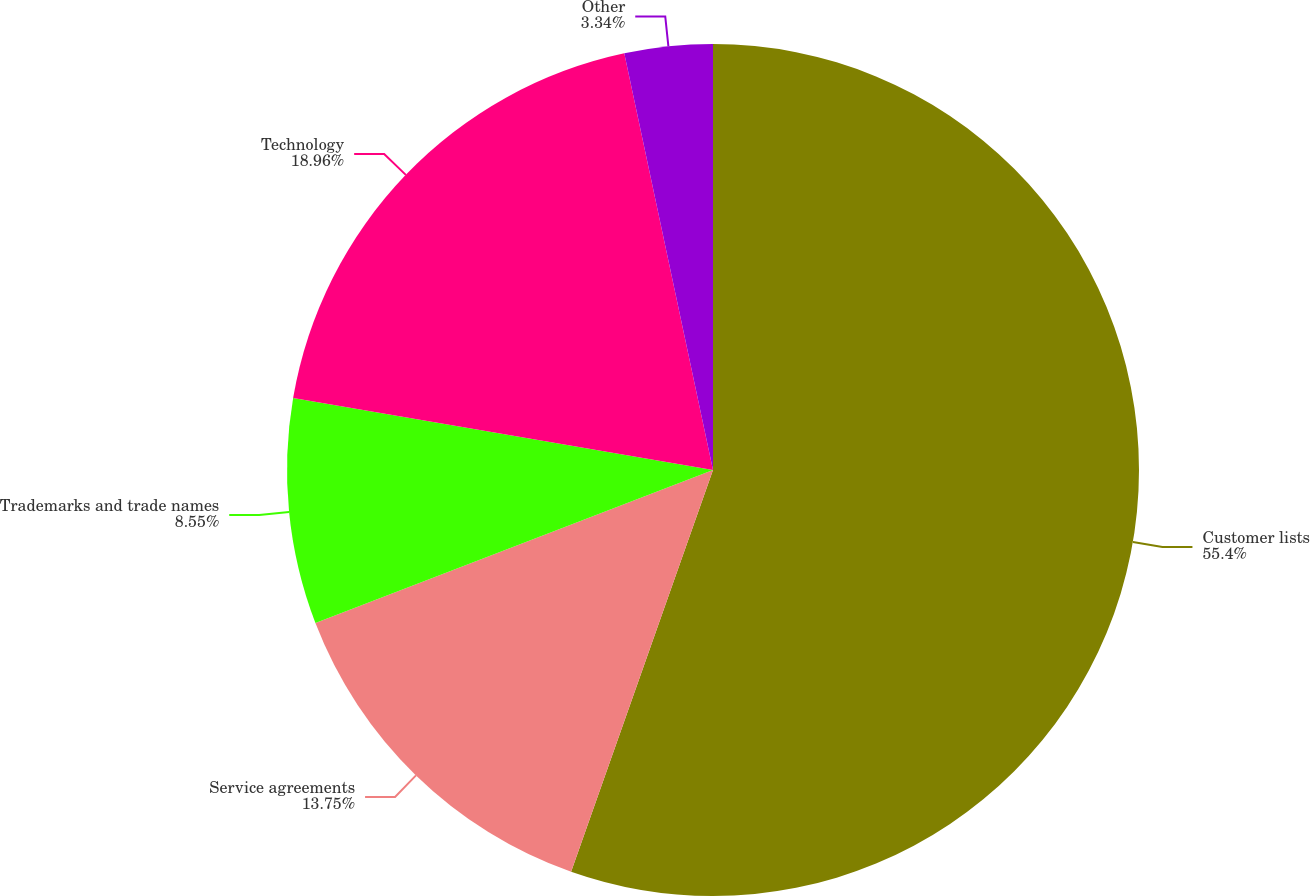<chart> <loc_0><loc_0><loc_500><loc_500><pie_chart><fcel>Customer lists<fcel>Service agreements<fcel>Trademarks and trade names<fcel>Technology<fcel>Other<nl><fcel>55.41%<fcel>13.75%<fcel>8.55%<fcel>18.96%<fcel>3.34%<nl></chart> 